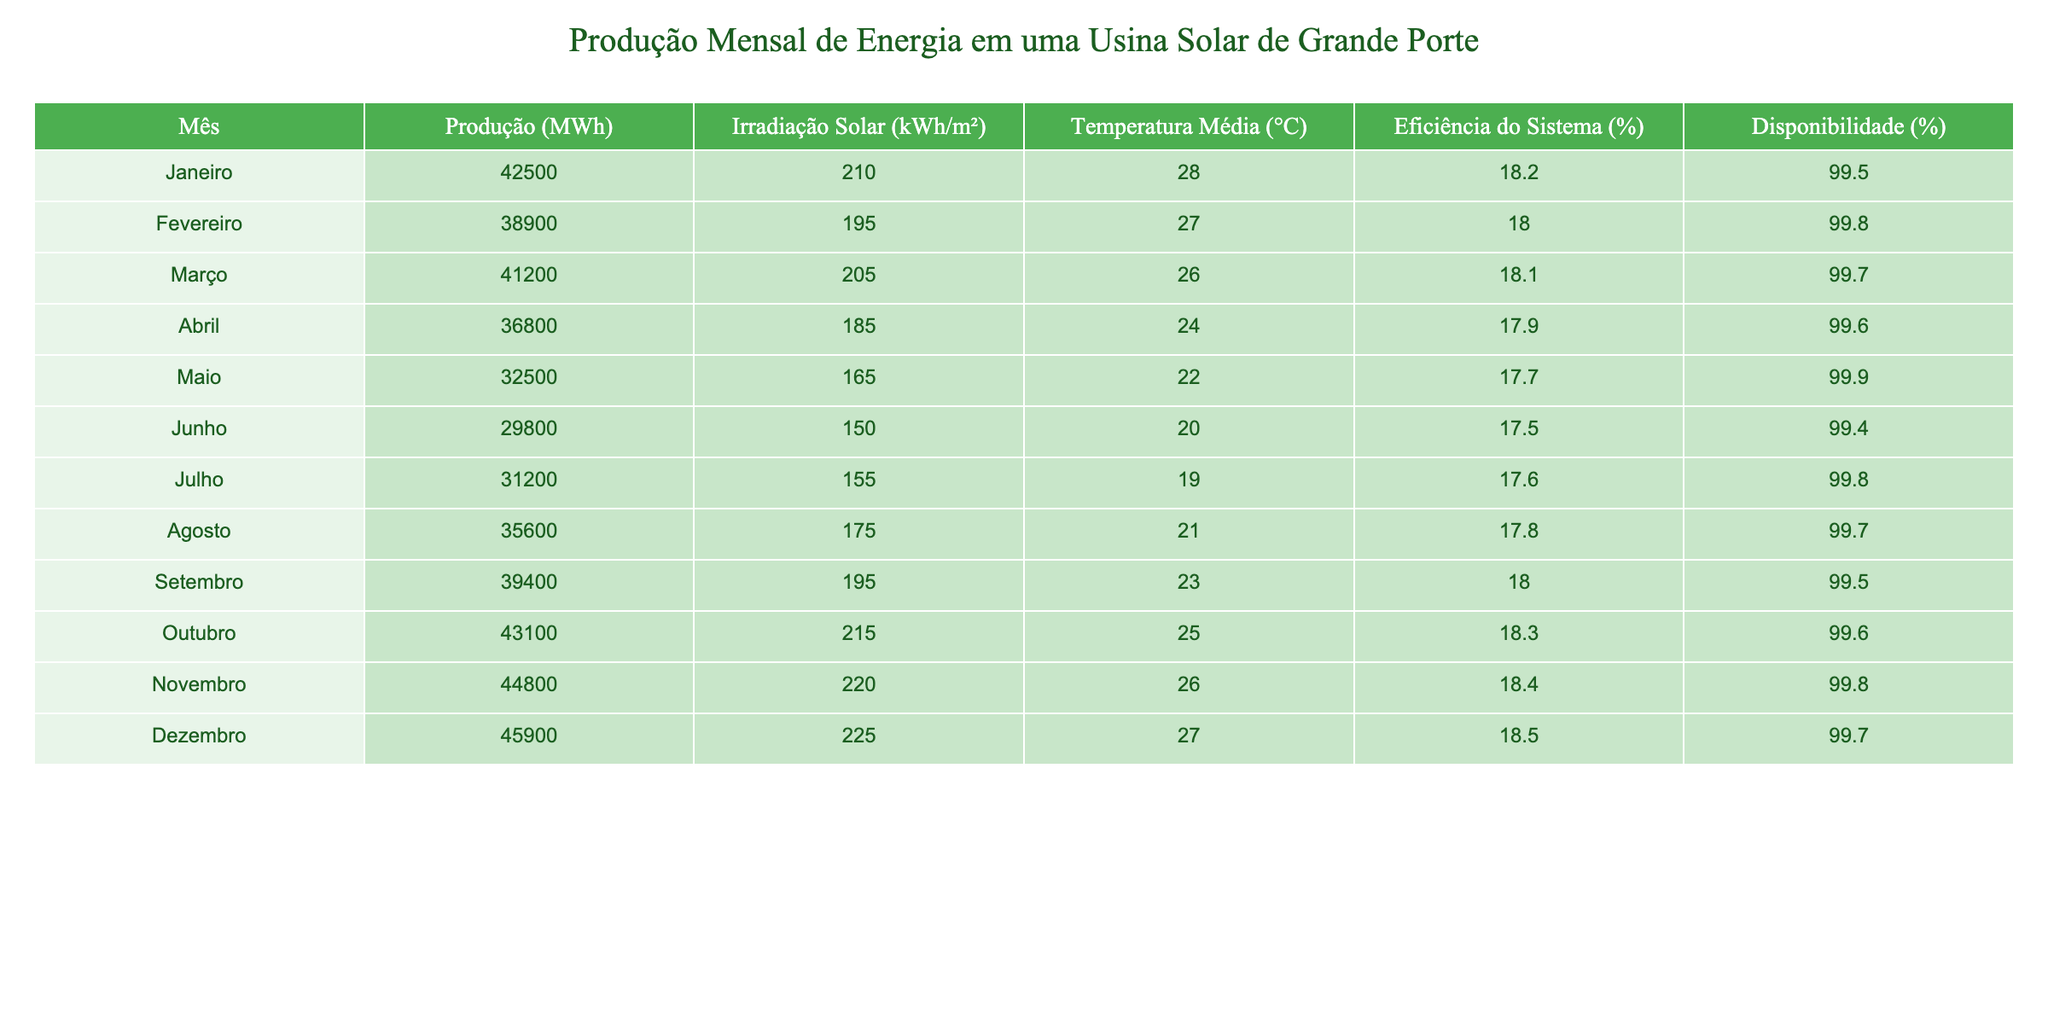Qual foi o mês com a maior produção de energia? Olhando na tabela, o mês de Dezembro apresenta a maior produção de energia, com 45900 MWh.
Answer: Dezembro Qual foi a produção total de energia nos meses de Maio a Julho? Somando a produção de Maio (32500 MWh), Junho (29800 MWh) e Julho (31200 MWh), temos 32500 + 29800 + 31200 = 93500 MWh.
Answer: 93500 MWh Qual foi a irradiação solar média no ano? Somando todas as irradiações solares e dividindo pelo número de meses: (210 + 195 + 205 + 185 + 165 + 150 + 155 + 175 + 195 + 215 + 220 + 225) / 12 = 194,58 kWh/m², aproximadamente.
Answer: 194,58 kWh/m² No mês de Novembro, a disponibilidade foi superior a 99%? A tabela mostra que a disponibilidade em Novembro é de 99,8%, que é superior a 99%.
Answer: Sim Qual mês teve a eficiência do sistema mais baixa e qual foi esse valor? Ao analisar a tabela, Junho teve a eficiência mais baixa, com 17,5%.
Answer: Junho e 17,5% Qual é a diferença na produção de energia entre Janeiro e Junho? A produção em Janeiro é de 42500 MWh e em Junho é de 29800 MWh. Portanto, a diferença é 42500 - 29800 = 12700 MWh.
Answer: 12700 MWh 